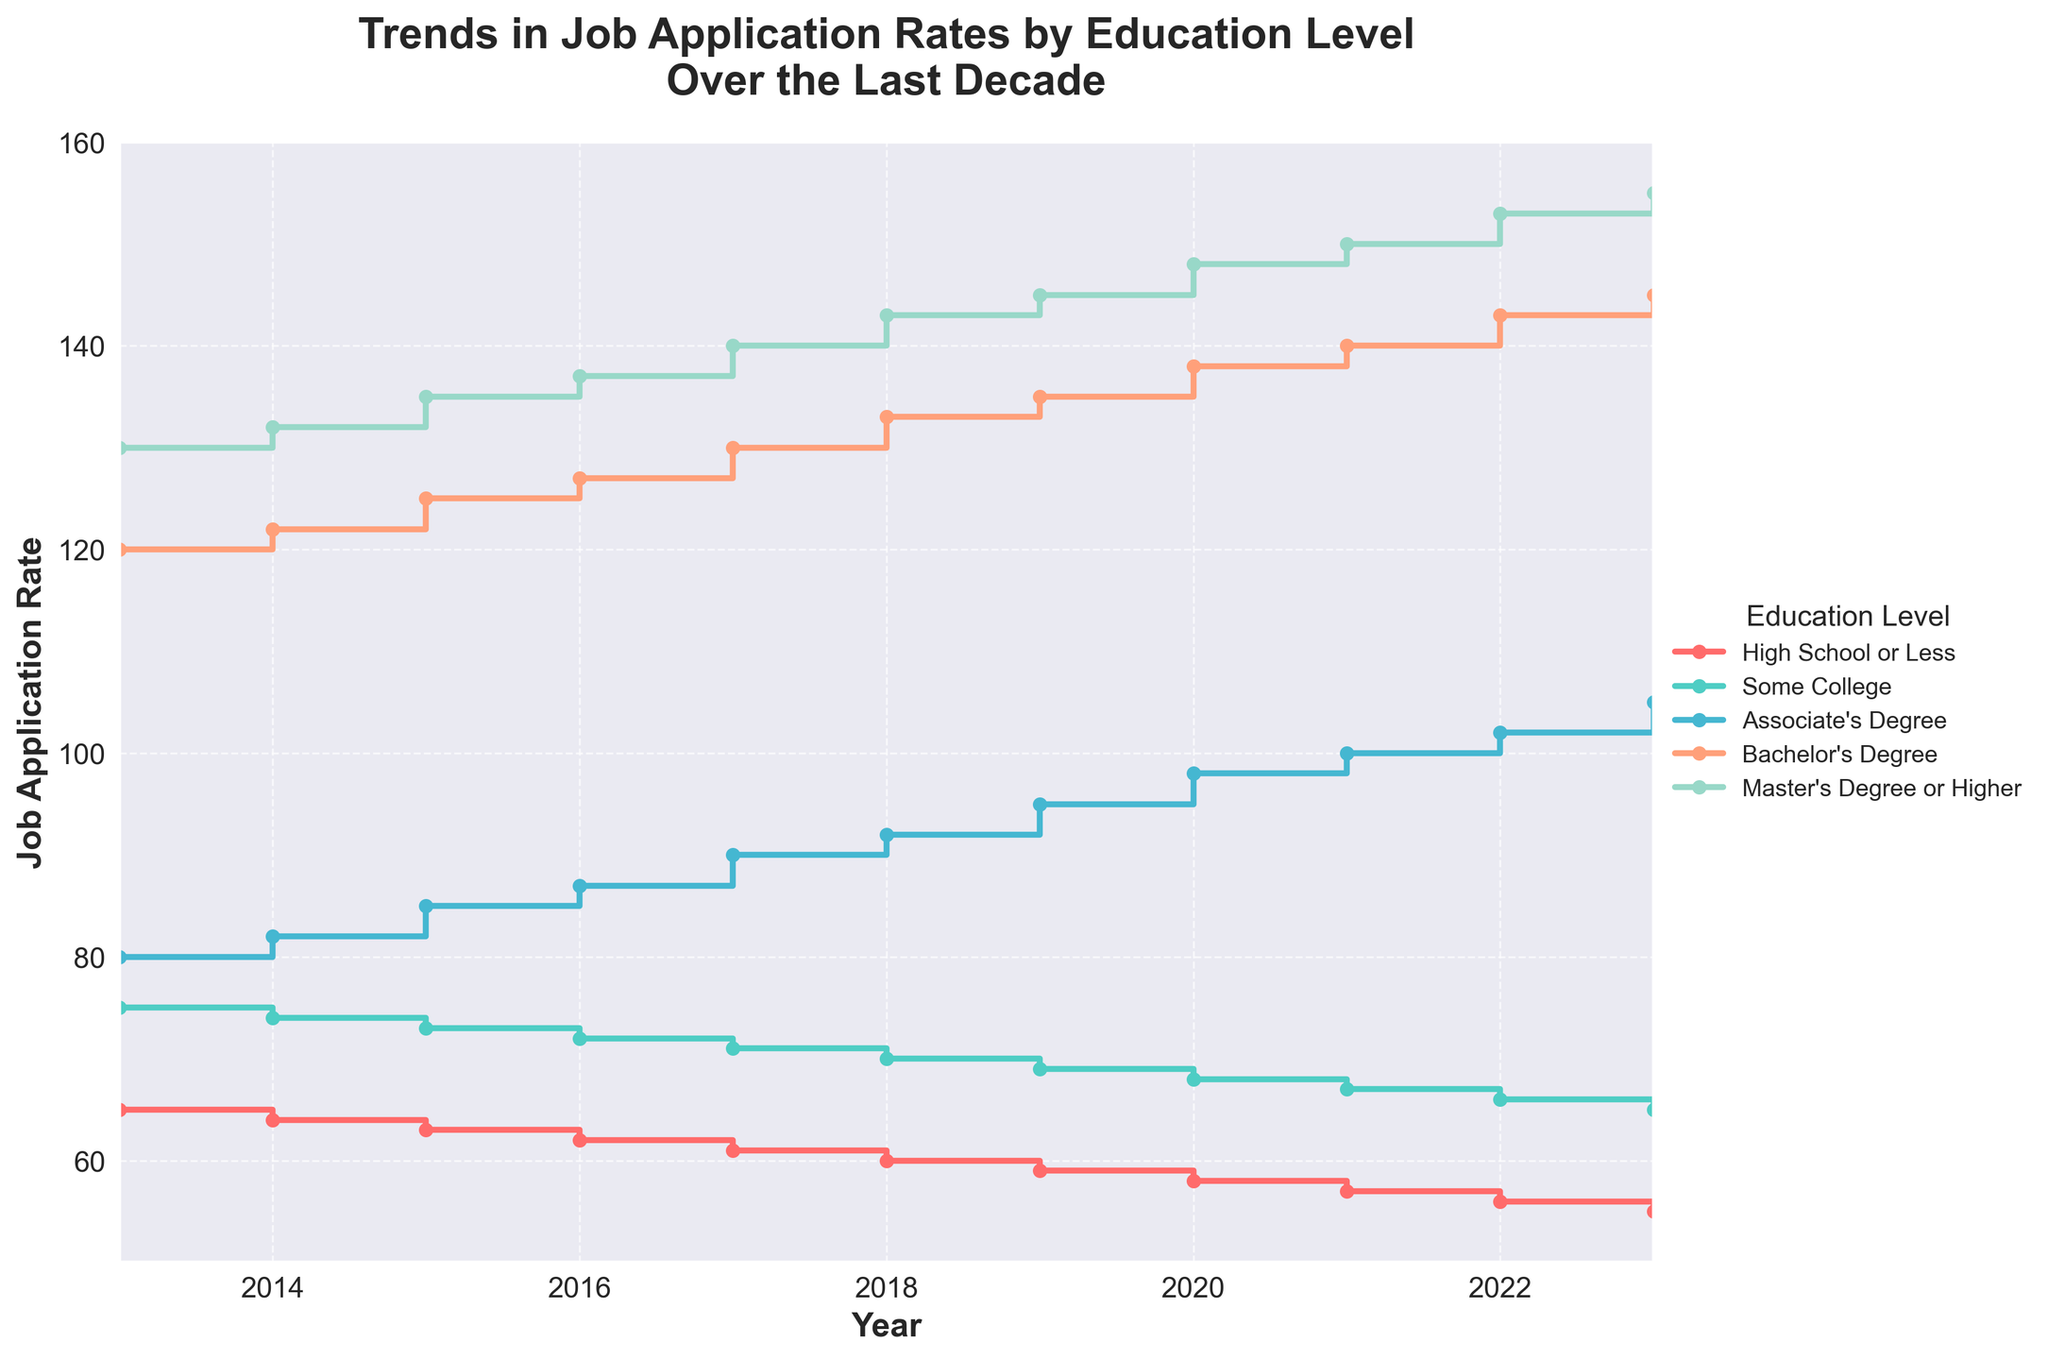What is the title of the figure? The title is written at the top of the figure.
Answer: Trends in Job Application Rates by Education Level Over the Last Decade What are the x-axis and y-axis labels? The labels can be found on the horizontal and vertical axes respectively.
Answer: Year, Job Application Rate How many education levels are compared in the figure? Count the distinct lines/legends represented in different colors.
Answer: Five How does the job application rate for people with a Bachelor's Degree change from 2013 to 2023? Follow the line representing the Bachelor's Degree from 2013 to 2023.
Answer: It increases from 120 to 145 Which education level has the lowest job application rate in 2023? Compare the final points of each line for the year 2023.
Answer: High School or Less Among the education levels, which one shows the most significant increase in job application rates from 2013 to 2023? Calculate the difference in job application rates from 2013 to 2023 for each line/education level.
Answer: Bachelor's Degree (25 increase) and Master's Degree or Higher (25 increase) Between which years did the job application rate for people with an Associate's Degree surpass those with Some College? Identify the year where the line for Associate's Degree crosses above the line for Some College.
Answer: It happened between 2015 and 2016 What is the overall trend for people with a Master's Degree or Higher from 2013 to 2023? Notice the general direction of the line representing Master's Degree or Higher over the years.
Answer: Increasing How does the job application rate for people with an associate's degree in 2021 compare to those with a bachelor's degree in the same year? Find the job application rates for Associate's Degree and Bachelor's Degree in 2021 and compare.
Answer: Bachelor's Degree is 40 higher than Associate's Degree (140 vs. 100) Which education level consistently shows a decrease in job application rates over the decade? Look for the line that continuously trends downward from 2013 to 2023.
Answer: High School or Less Is there any year where any two education levels have the same job application rate? If yes, which year and levels? Check if any two lines intersect at any point.
Answer: No 